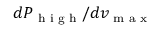Convert formula to latex. <formula><loc_0><loc_0><loc_500><loc_500>d P _ { h i g h } / d v _ { \max }</formula> 